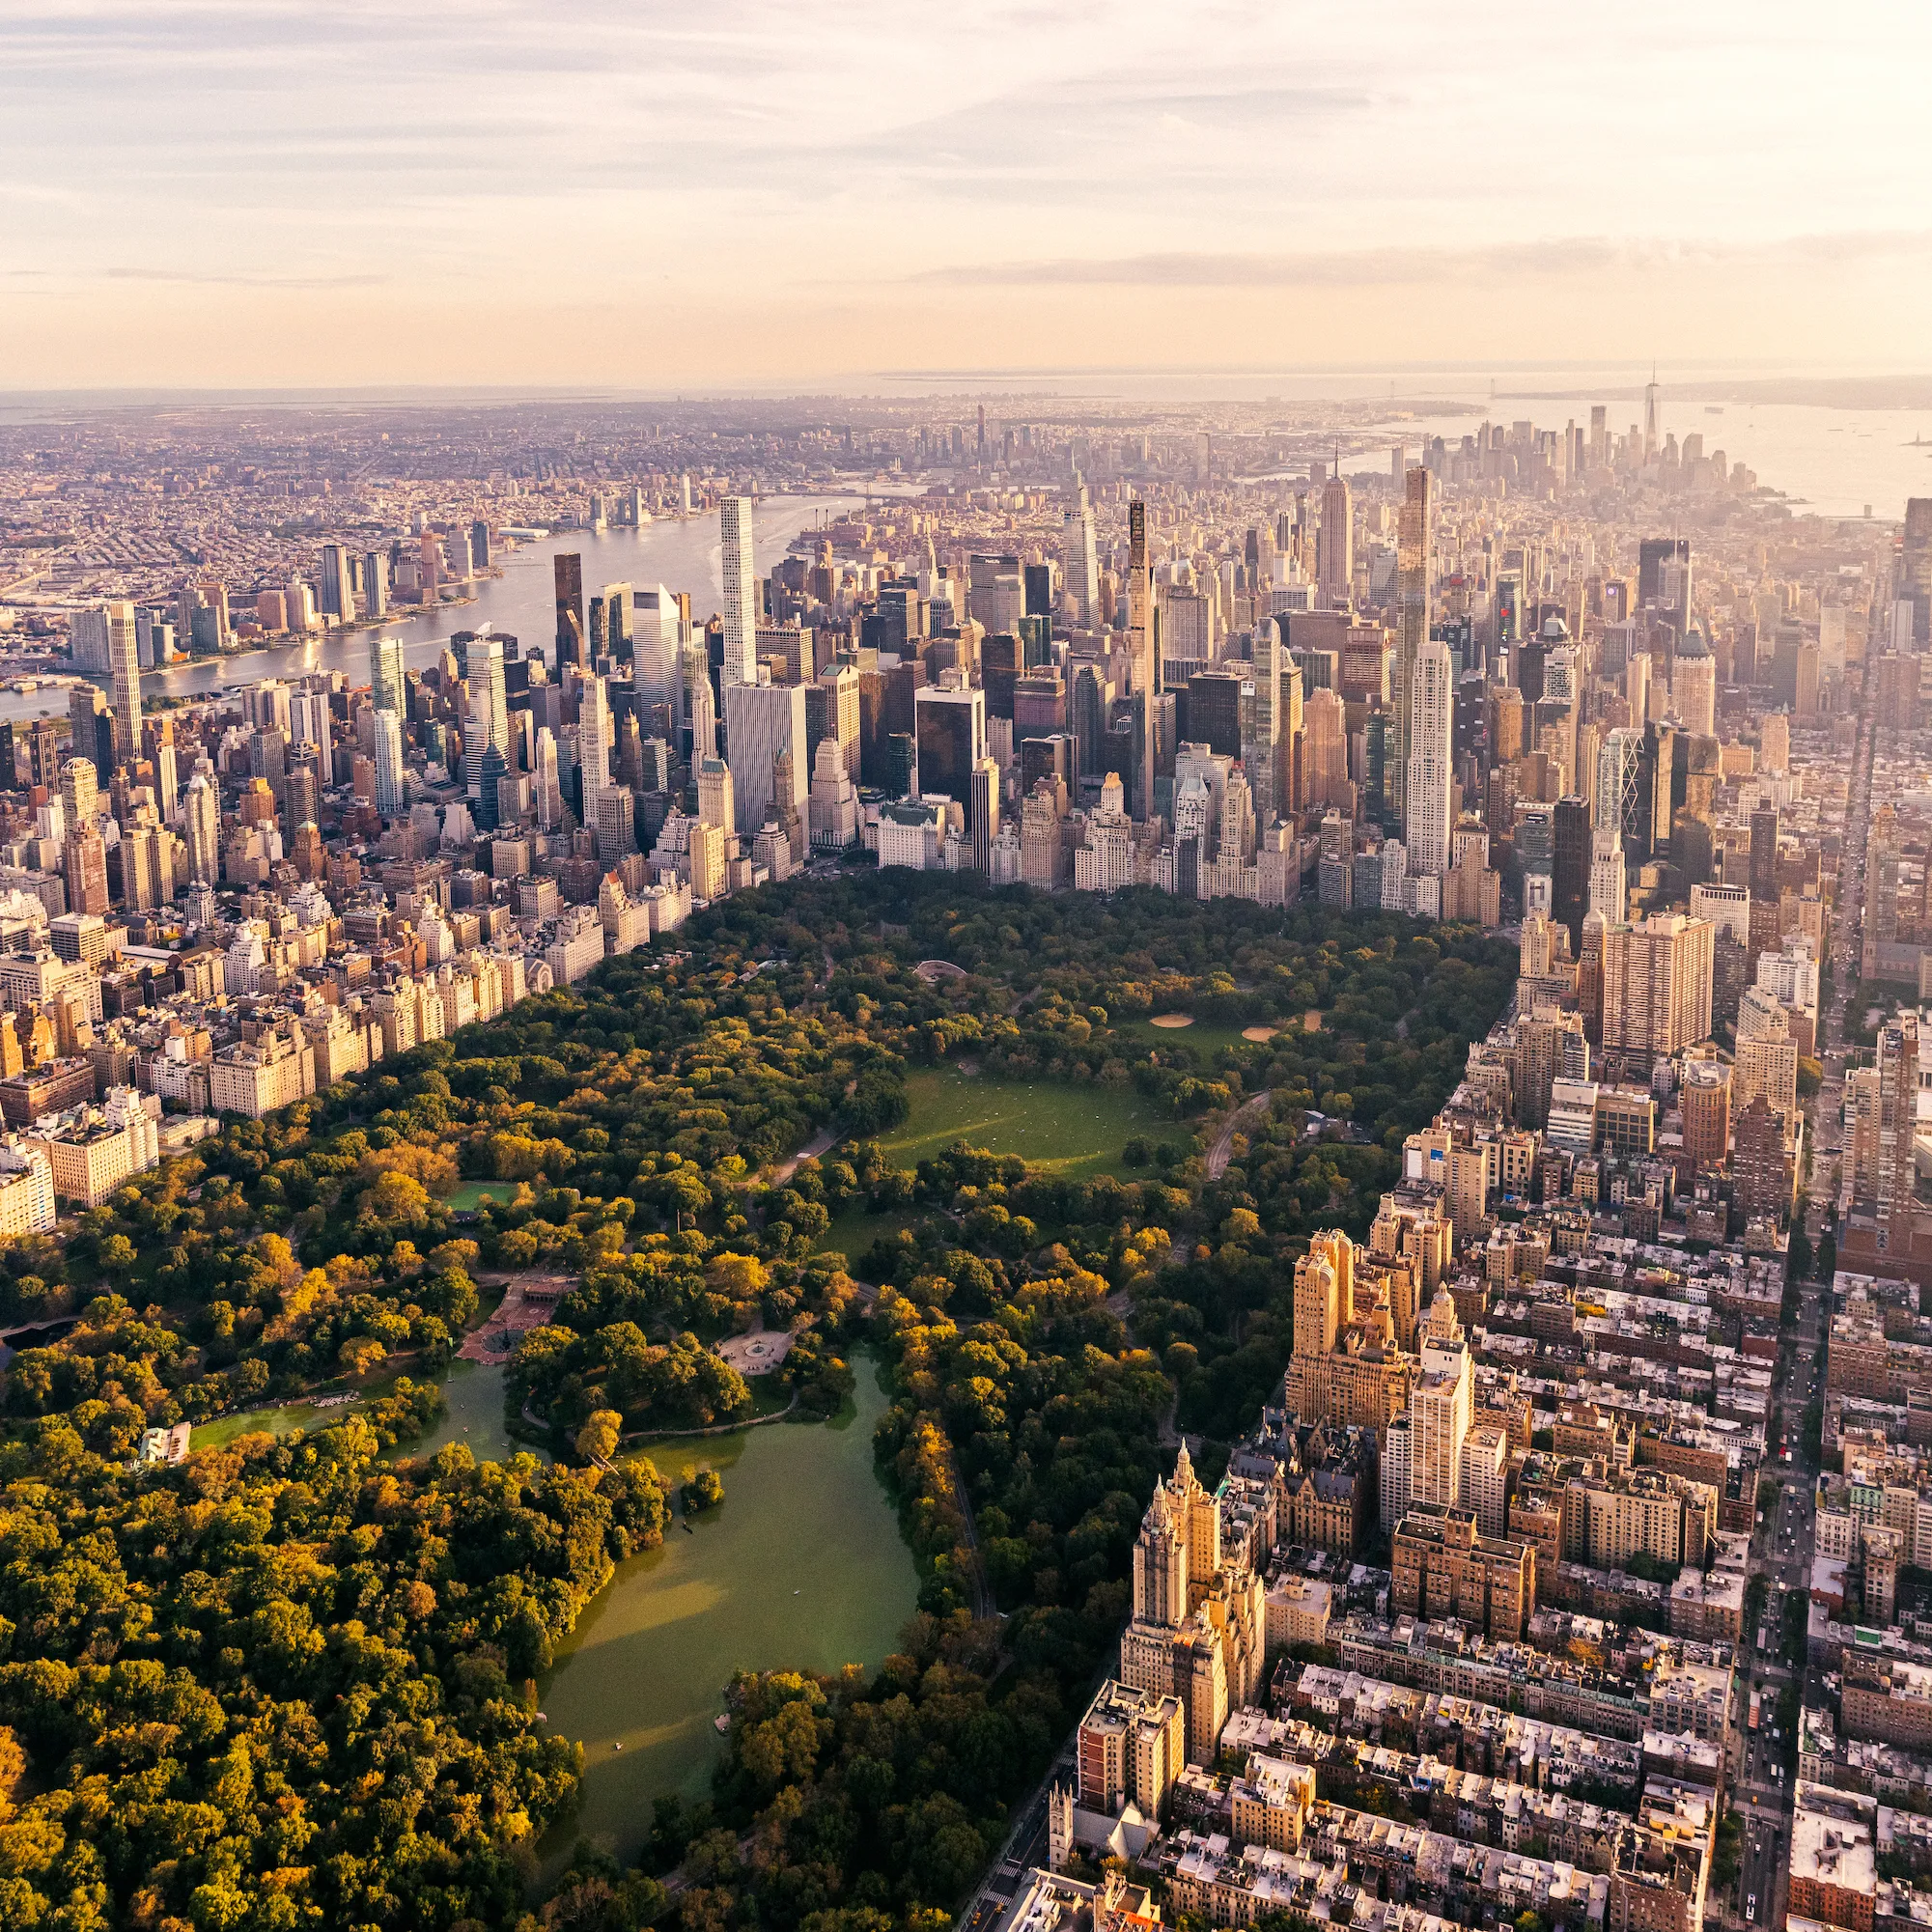What activities might people be enjoying in Central Park in this view? In this serene scene of Central Park, people might be engaging in various recreational activities such as jogging or walking along the numerous trails, rowing in the boats on the lake, or simply lounging on the grass. The expansive green fields are perfect for picnics and outdoor sports, while the shaded areas under the trees offer a cool retreat for reading or relaxing. Could you tell me more about the significance of the lake in the center? Certainly! The large body of water in the center of the park is the Jacqueline Kennedy Onassis Reservoir. It is not only a scenic highlight of Central Park but also serves as a critical habitat for various bird species and aquatic life. The reservoir is circled by a running track popular among local joggers and offers some of the best views of the city skyline, making it a favored spot for photographers and nature enthusiasts alike. 